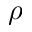<formula> <loc_0><loc_0><loc_500><loc_500>\rho</formula> 